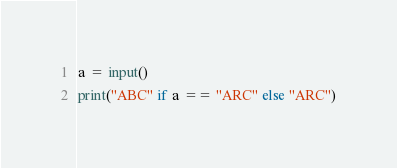Convert code to text. <code><loc_0><loc_0><loc_500><loc_500><_Python_>a = input()
print("ABC" if a == "ARC" else "ARC")</code> 